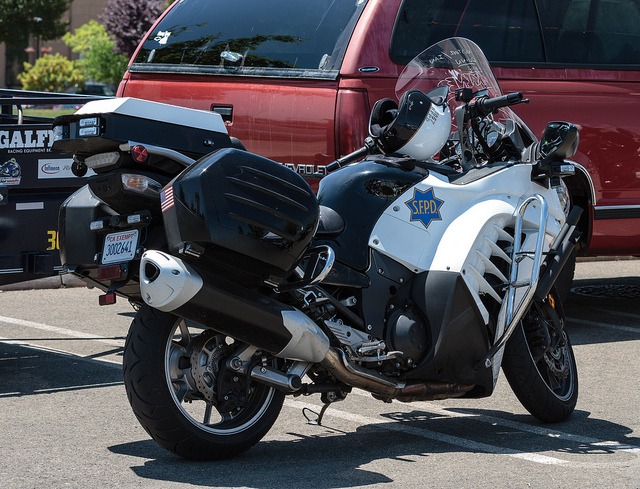Please extract the text content from this image. SFPD 3002641 GALF 